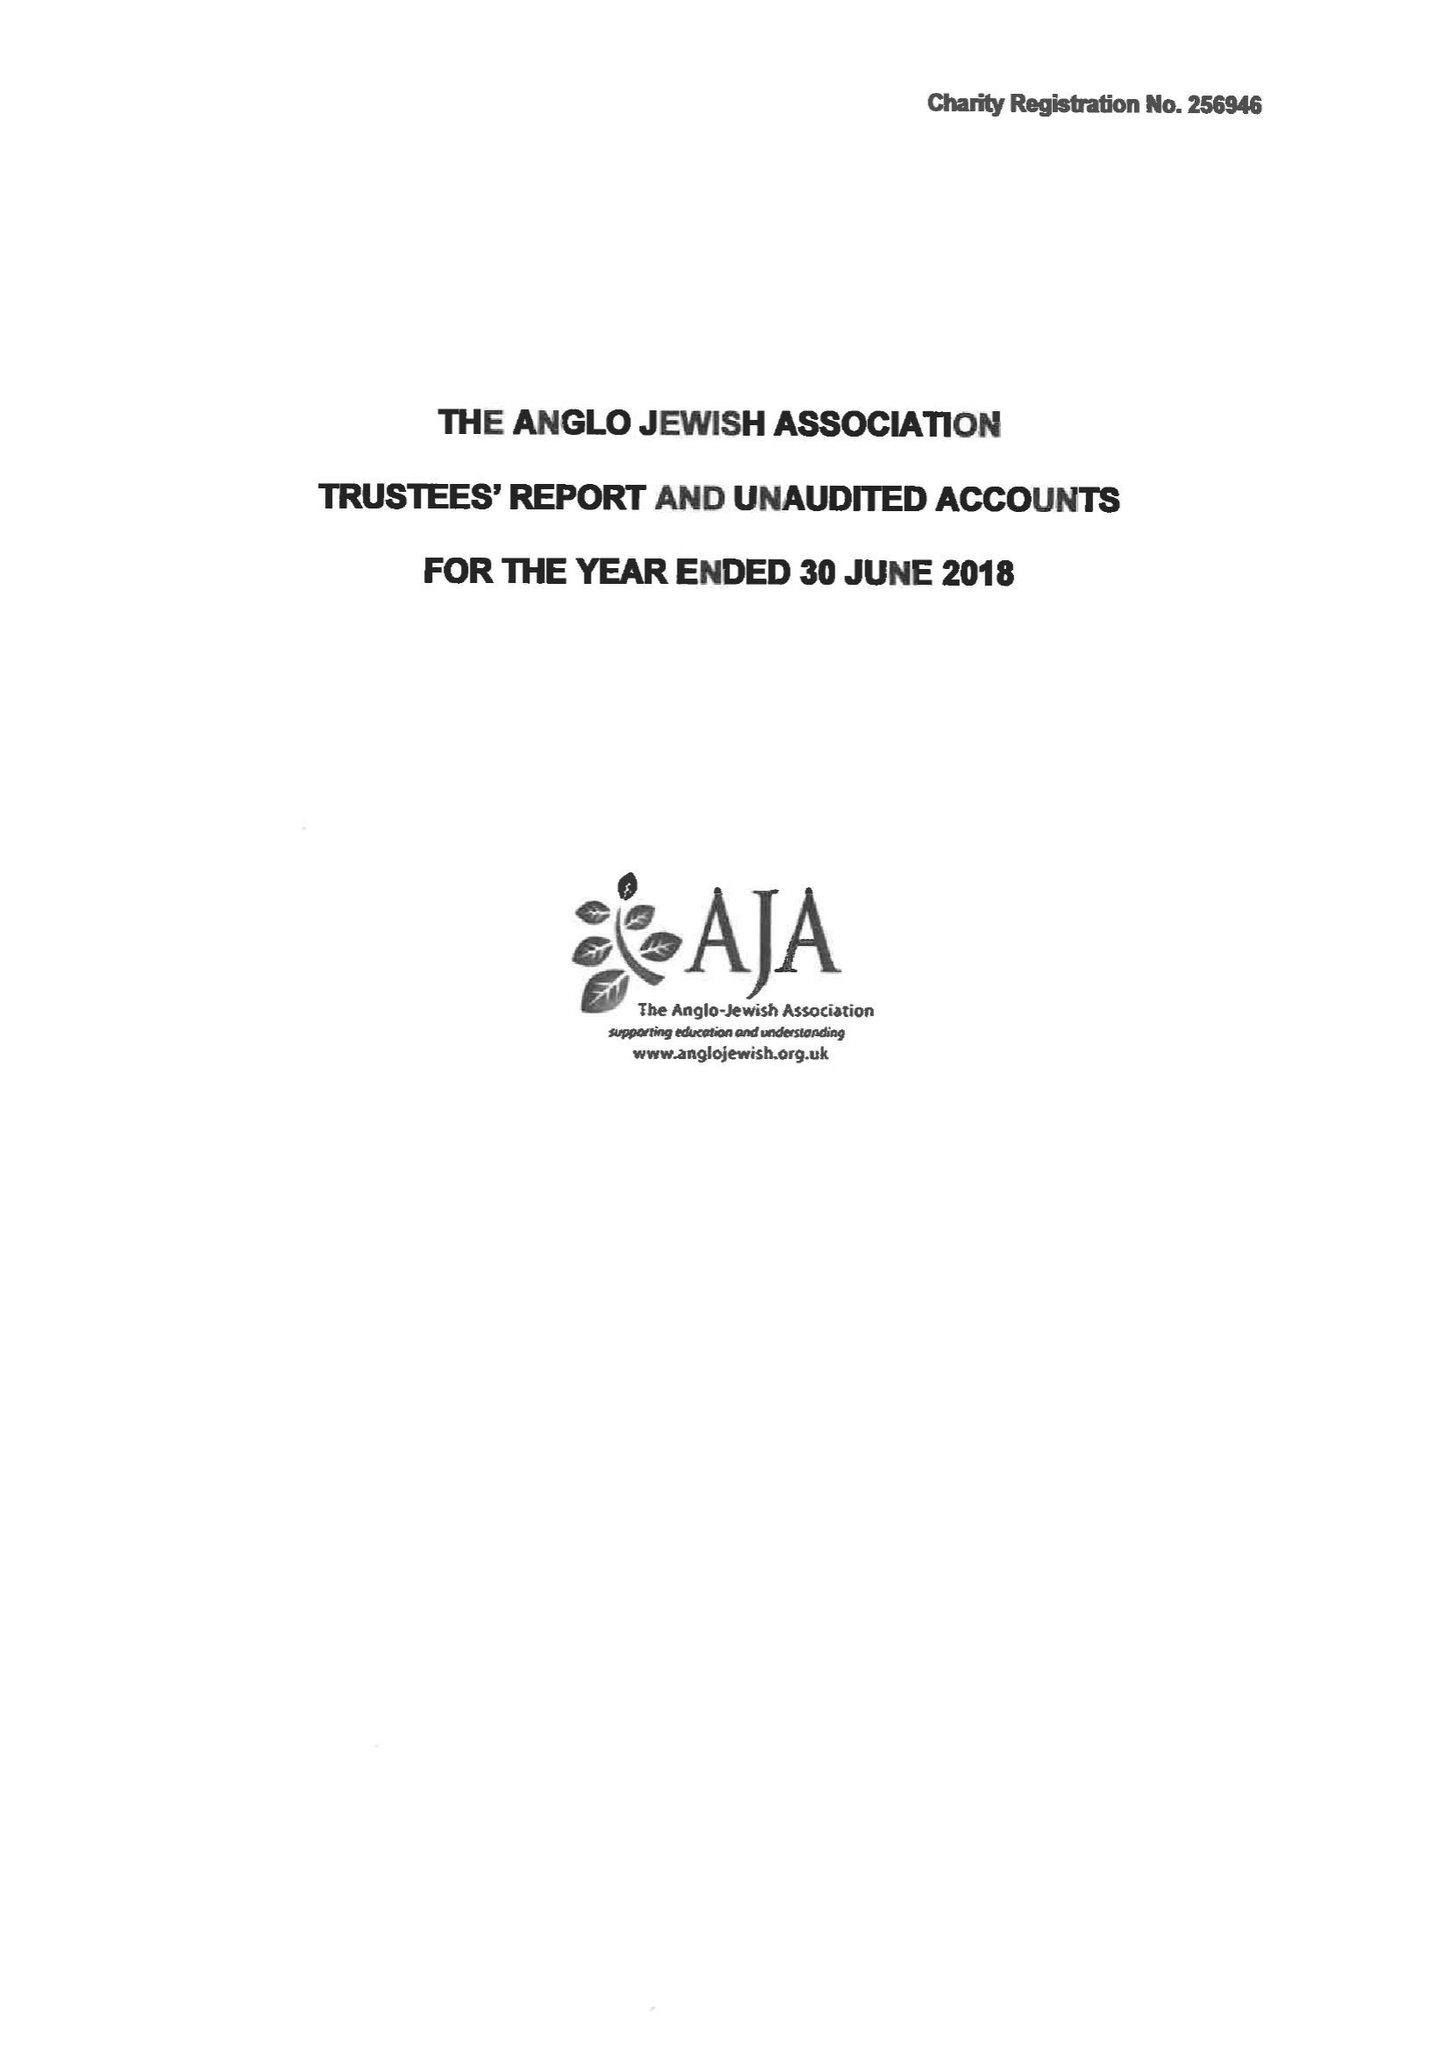What is the value for the address__postcode?
Answer the question using a single word or phrase. NW6 2EG 